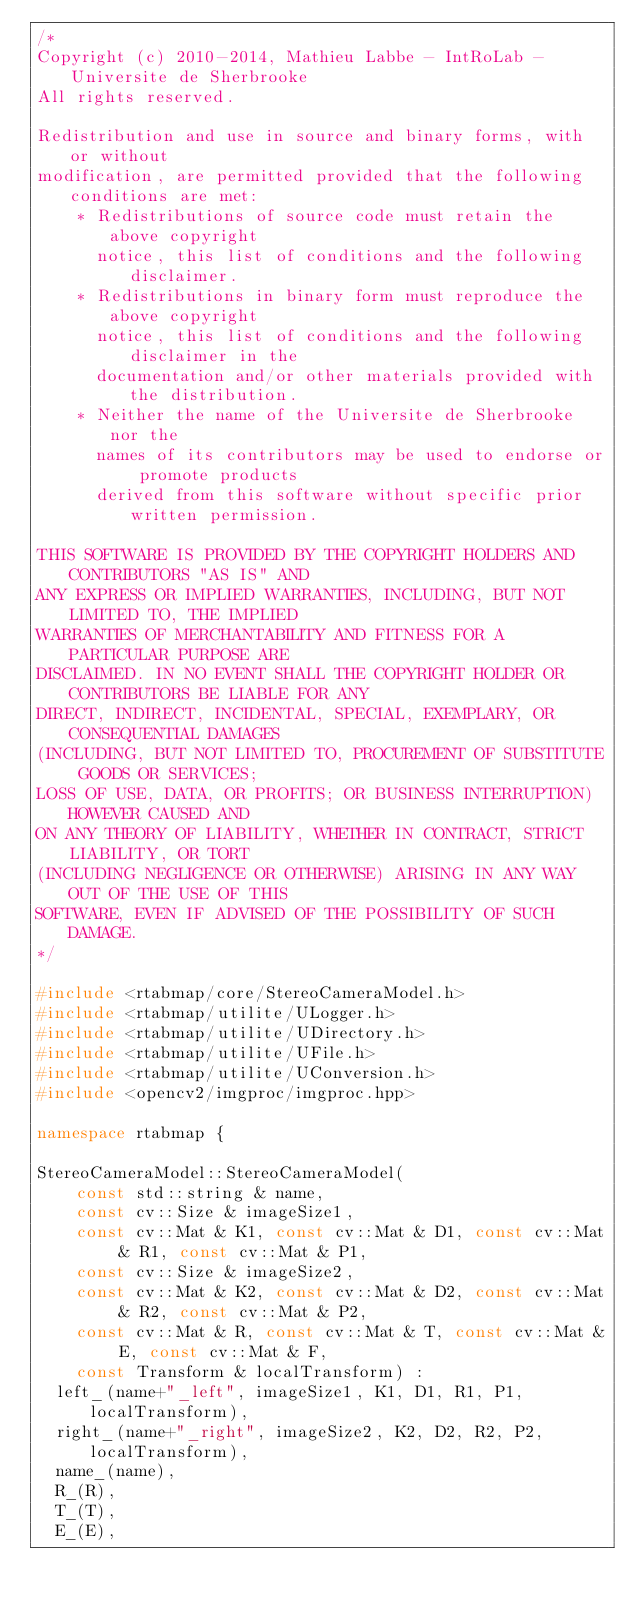Convert code to text. <code><loc_0><loc_0><loc_500><loc_500><_C++_>/*
Copyright (c) 2010-2014, Mathieu Labbe - IntRoLab - Universite de Sherbrooke
All rights reserved.

Redistribution and use in source and binary forms, with or without
modification, are permitted provided that the following conditions are met:
    * Redistributions of source code must retain the above copyright
      notice, this list of conditions and the following disclaimer.
    * Redistributions in binary form must reproduce the above copyright
      notice, this list of conditions and the following disclaimer in the
      documentation and/or other materials provided with the distribution.
    * Neither the name of the Universite de Sherbrooke nor the
      names of its contributors may be used to endorse or promote products
      derived from this software without specific prior written permission.

THIS SOFTWARE IS PROVIDED BY THE COPYRIGHT HOLDERS AND CONTRIBUTORS "AS IS" AND
ANY EXPRESS OR IMPLIED WARRANTIES, INCLUDING, BUT NOT LIMITED TO, THE IMPLIED
WARRANTIES OF MERCHANTABILITY AND FITNESS FOR A PARTICULAR PURPOSE ARE
DISCLAIMED. IN NO EVENT SHALL THE COPYRIGHT HOLDER OR CONTRIBUTORS BE LIABLE FOR ANY
DIRECT, INDIRECT, INCIDENTAL, SPECIAL, EXEMPLARY, OR CONSEQUENTIAL DAMAGES
(INCLUDING, BUT NOT LIMITED TO, PROCUREMENT OF SUBSTITUTE GOODS OR SERVICES;
LOSS OF USE, DATA, OR PROFITS; OR BUSINESS INTERRUPTION) HOWEVER CAUSED AND
ON ANY THEORY OF LIABILITY, WHETHER IN CONTRACT, STRICT LIABILITY, OR TORT
(INCLUDING NEGLIGENCE OR OTHERWISE) ARISING IN ANY WAY OUT OF THE USE OF THIS
SOFTWARE, EVEN IF ADVISED OF THE POSSIBILITY OF SUCH DAMAGE.
*/

#include <rtabmap/core/StereoCameraModel.h>
#include <rtabmap/utilite/ULogger.h>
#include <rtabmap/utilite/UDirectory.h>
#include <rtabmap/utilite/UFile.h>
#include <rtabmap/utilite/UConversion.h>
#include <opencv2/imgproc/imgproc.hpp>

namespace rtabmap {

StereoCameraModel::StereoCameraModel(
		const std::string & name,
		const cv::Size & imageSize1,
		const cv::Mat & K1, const cv::Mat & D1, const cv::Mat & R1, const cv::Mat & P1,
		const cv::Size & imageSize2,
		const cv::Mat & K2, const cv::Mat & D2, const cv::Mat & R2, const cv::Mat & P2,
		const cv::Mat & R, const cv::Mat & T, const cv::Mat & E, const cv::Mat & F,
		const Transform & localTransform) :
	left_(name+"_left", imageSize1, K1, D1, R1, P1, localTransform),
	right_(name+"_right", imageSize2, K2, D2, R2, P2, localTransform),
	name_(name),
	R_(R),
	T_(T),
	E_(E),</code> 